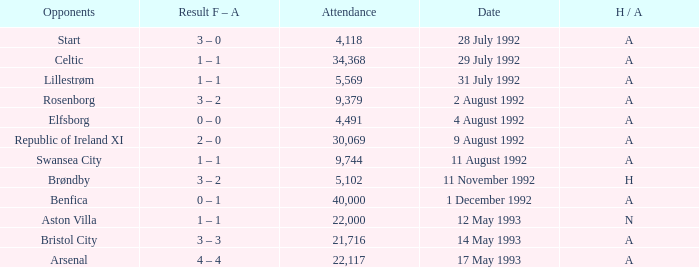Which Result F-A has Opponents of rosenborg? 3 – 2. 